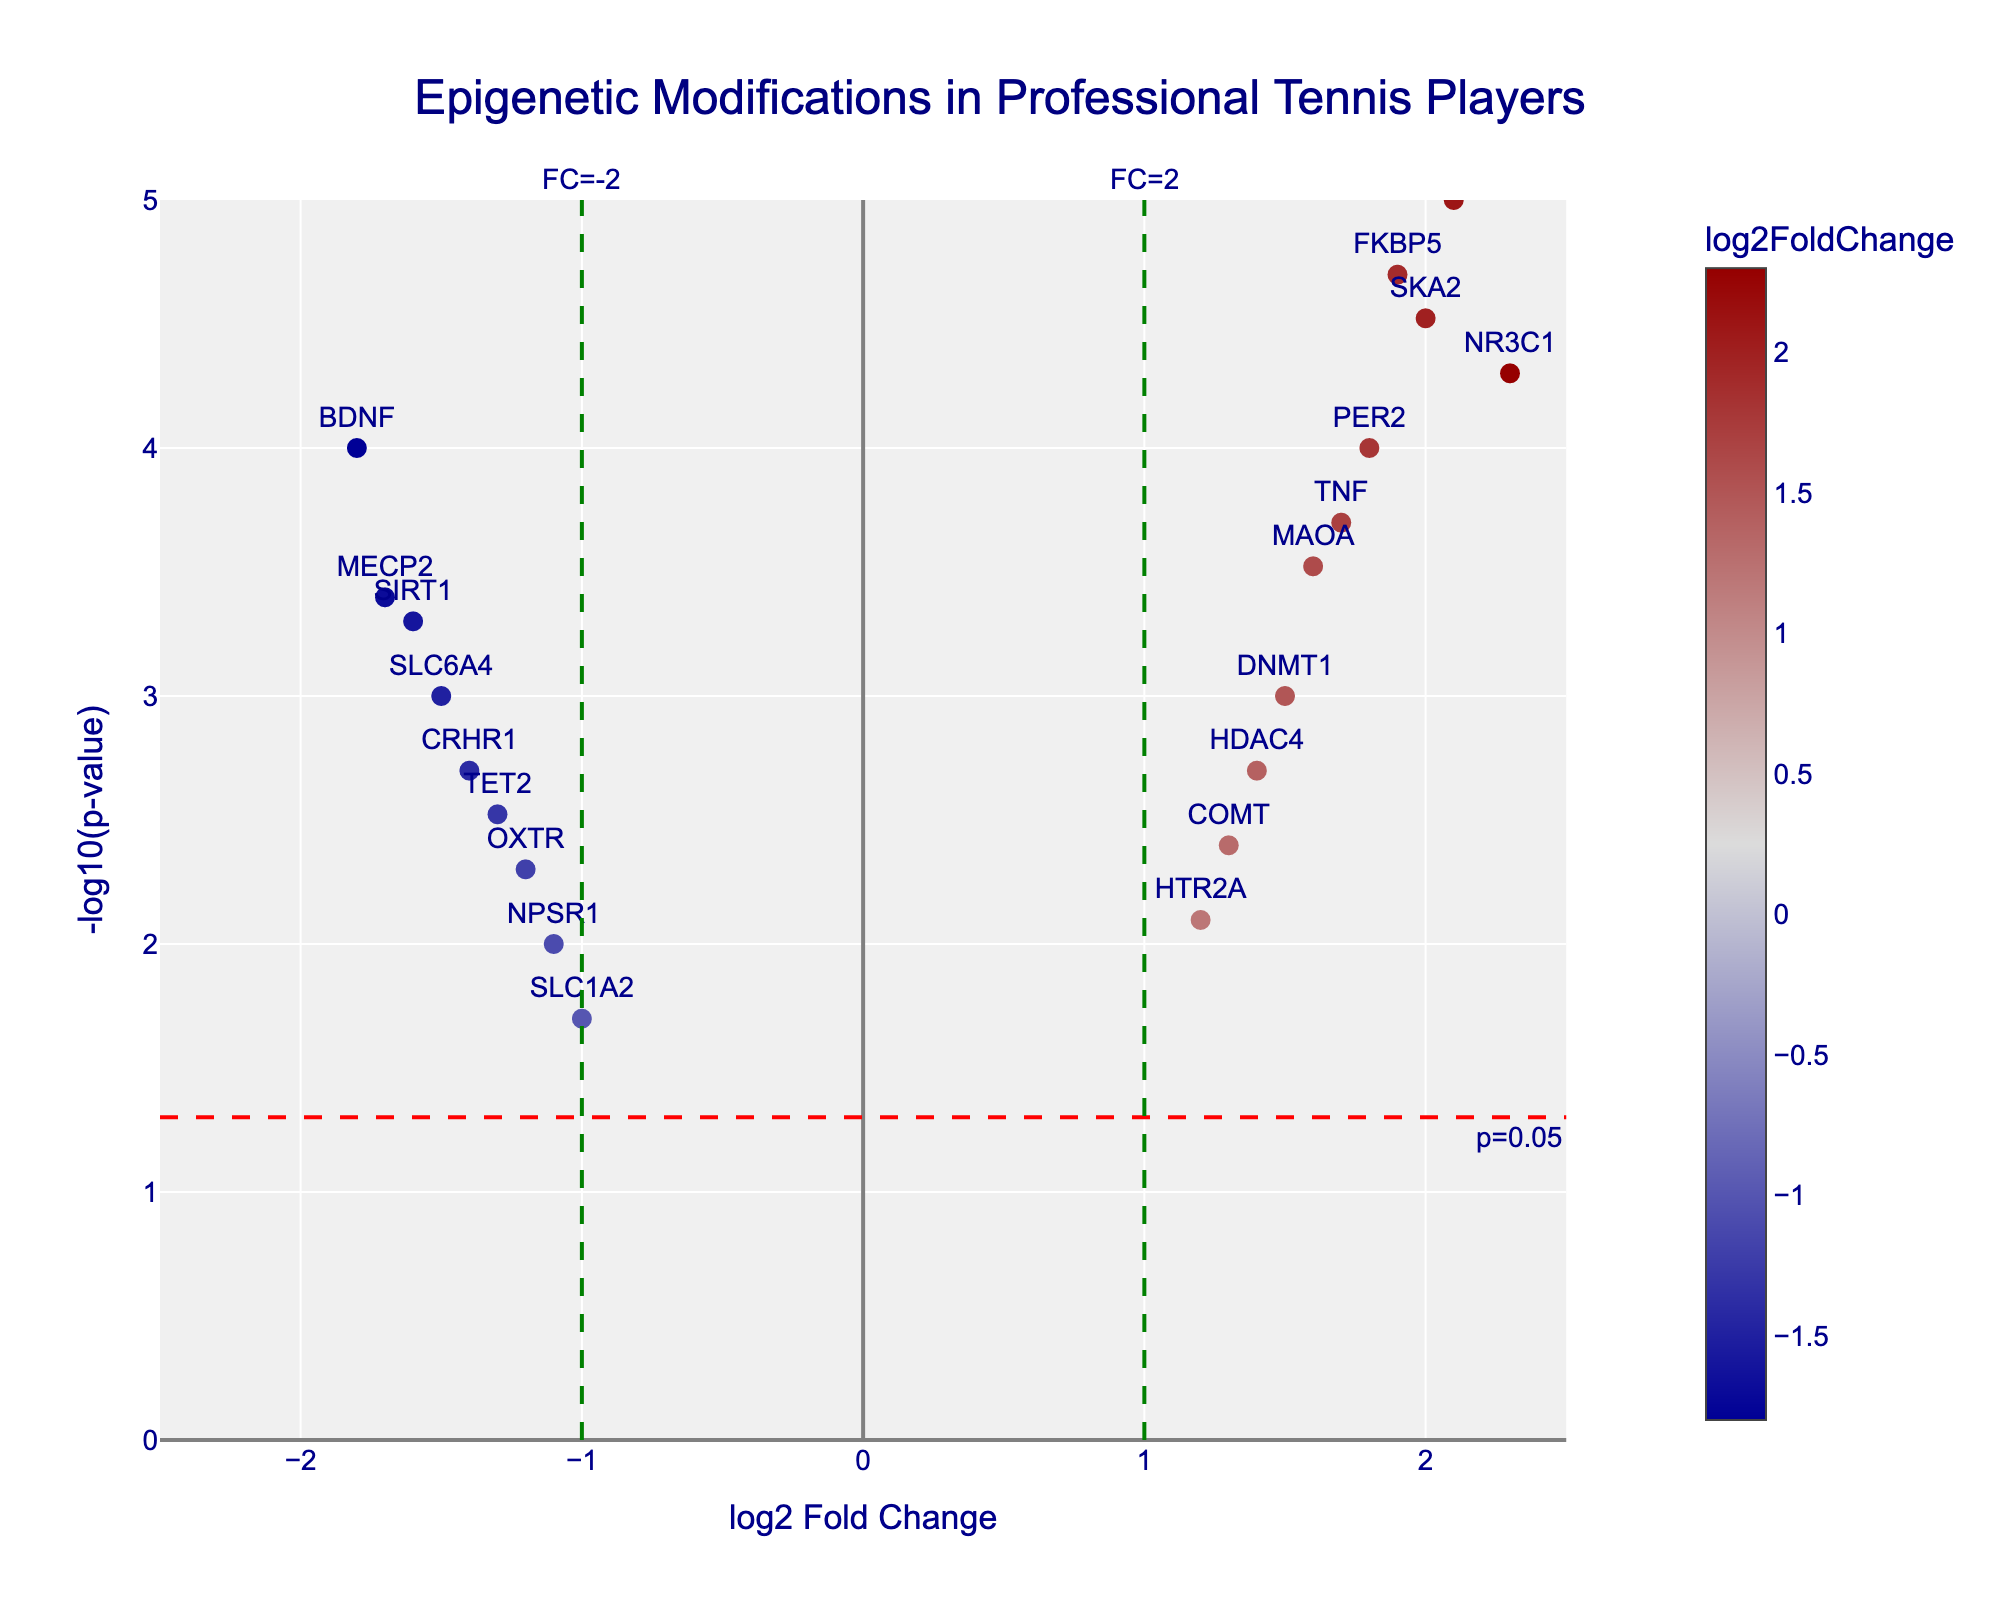How many genes are plotted in the figure? Count the number of data points in the figure, which represents the genes.
Answer: 20 Which gene has the highest -log10(p-value)? Identify the point on the y-axis that is the highest, and refer to the gene name labeled at that point.
Answer: IL6 What is the range of log2 Fold Change values shown in the plot? The x-axis ranges from -2.5 to 2.5 as indicated by the axis labels.
Answer: -2.5 to 2.5 Which genes have a log2 Fold Change greater than 2? Identify genes where the x-values (log2 Fold Change) are greater than 2.
Answer: NR3C1 and IL6 What is the p-value threshold indicated by the red dashed line? The red dashed line on the y-axis represents the threshold, marked as p=0.05.
Answer: 0.05 How many genes have a p-value less than 0.05? Count the number of points above the red dashed line marked at -log10(p-value) of 1.3.
Answer: 17 Which gene has the lowest log2 Fold Change? Identify the point on the x-axis that is the lowest, and refer to the gene name labeled at that point.
Answer: BDNF Which genes are both significantly upregulated (log2 Fold Change > 1) and have a p-value < 0.0001? Identify genes where x-values are greater than 1 and y-values are greater than 4 (as -log10(0.0001) = 4).
Answer: NR3C1 and SKA2 How does the annotation for the gene MECP2 appear on the plot? Find the gene MECP2 on the plot and describe its appearance, particularly its log2 Fold Change and -log10(p-value).
Answer: MECP2 has a log2 Fold Change of -1.7 and a -log10(p-value) of 3.4 What does the color scale represent in the plot? Refer to the color scale bar title provided in the figure.
Answer: log2 Fold Change 